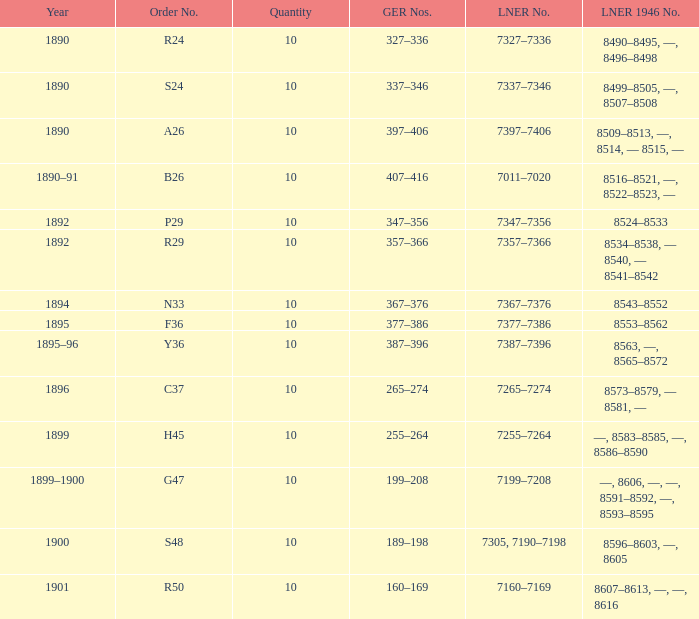What is order S24's LNER 1946 number? 8499–8505, —, 8507–8508. 